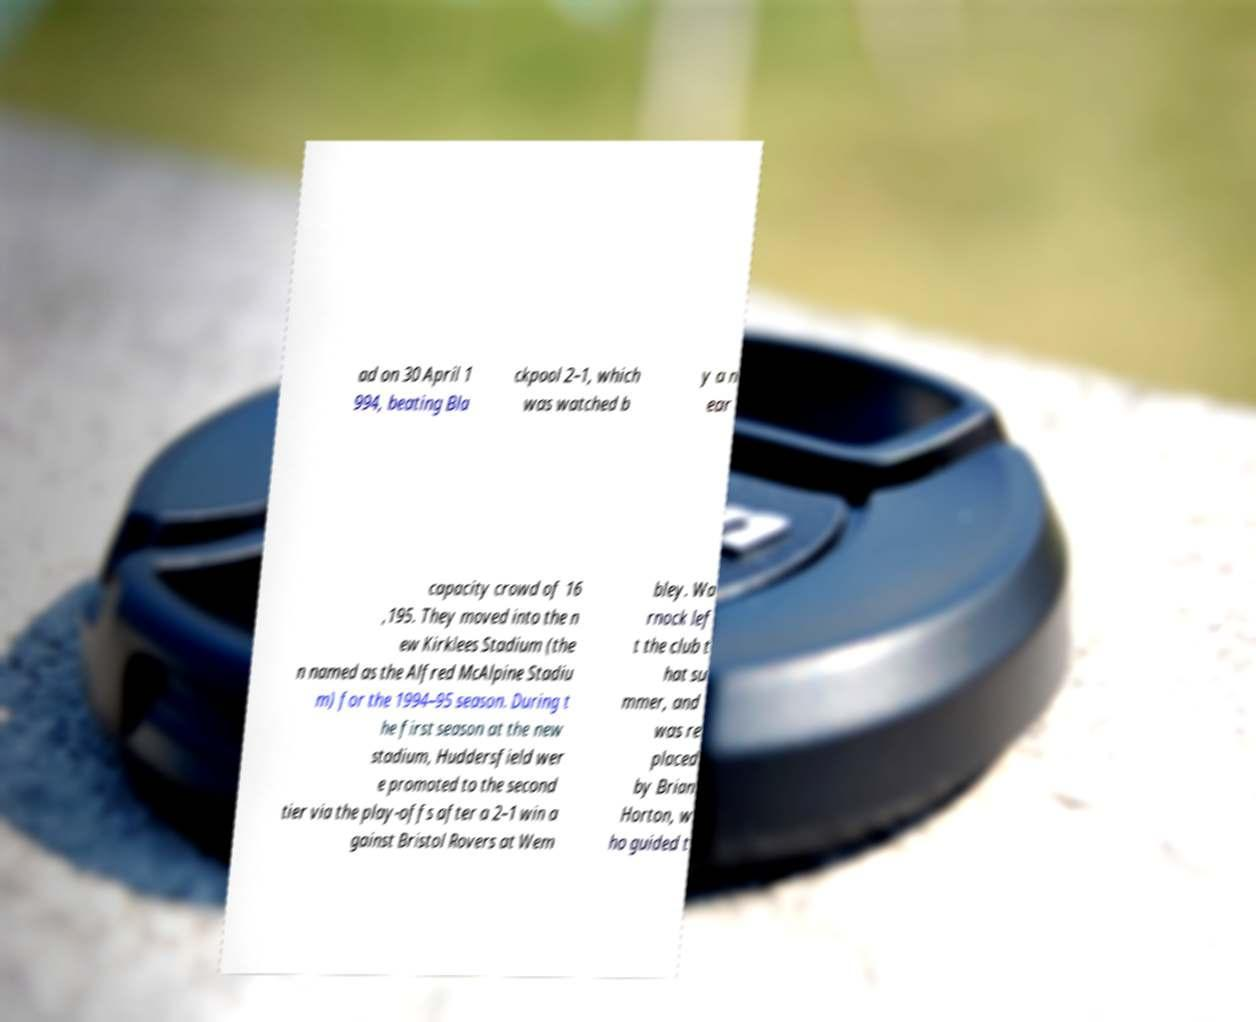Could you extract and type out the text from this image? ad on 30 April 1 994, beating Bla ckpool 2–1, which was watched b y a n ear capacity crowd of 16 ,195. They moved into the n ew Kirklees Stadium (the n named as the Alfred McAlpine Stadiu m) for the 1994–95 season. During t he first season at the new stadium, Huddersfield wer e promoted to the second tier via the play-offs after a 2–1 win a gainst Bristol Rovers at Wem bley. Wa rnock lef t the club t hat su mmer, and was re placed by Brian Horton, w ho guided t 